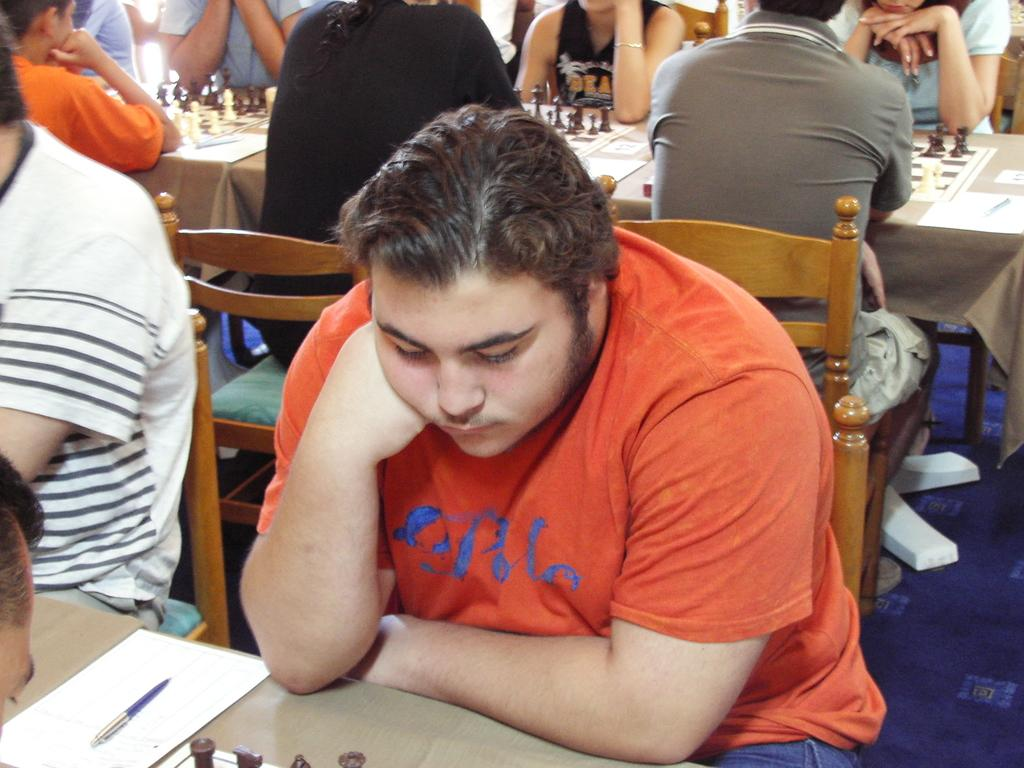How many people are in the image? There is a group of people in the image. What are the people doing in the image? The people are sitting on chairs. What is on the table in front of the people? There is a chess board and a paper on the table. What object on the table might be used for writing? There is a pen on the table. What type of skirt is the actor wearing in the image? There is no actor or skirt present in the image. Is there a door visible in the image? No, there is no door visible in the image. 